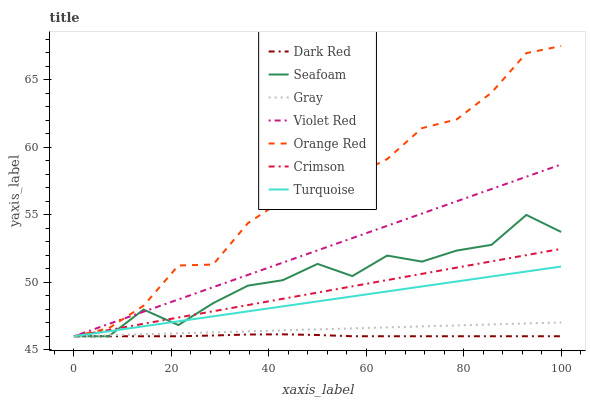Does Dark Red have the minimum area under the curve?
Answer yes or no. Yes. Does Orange Red have the maximum area under the curve?
Answer yes or no. Yes. Does Violet Red have the minimum area under the curve?
Answer yes or no. No. Does Violet Red have the maximum area under the curve?
Answer yes or no. No. Is Turquoise the smoothest?
Answer yes or no. Yes. Is Seafoam the roughest?
Answer yes or no. Yes. Is Violet Red the smoothest?
Answer yes or no. No. Is Violet Red the roughest?
Answer yes or no. No. Does Gray have the lowest value?
Answer yes or no. Yes. Does Orange Red have the highest value?
Answer yes or no. Yes. Does Violet Red have the highest value?
Answer yes or no. No. Does Violet Red intersect Dark Red?
Answer yes or no. Yes. Is Violet Red less than Dark Red?
Answer yes or no. No. Is Violet Red greater than Dark Red?
Answer yes or no. No. 